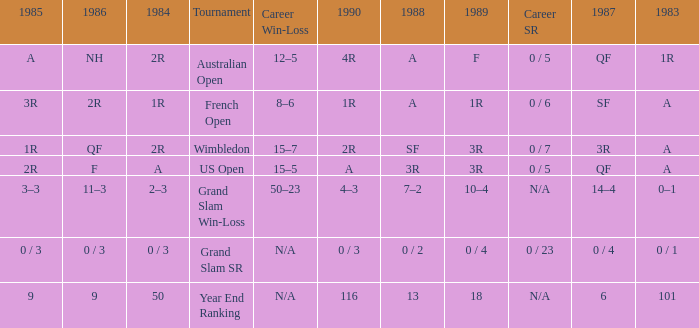What tournament has 0 / 5 as career SR and A as 1983? US Open. 